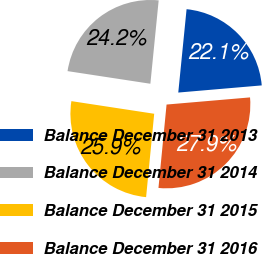Convert chart. <chart><loc_0><loc_0><loc_500><loc_500><pie_chart><fcel>Balance December 31 2013<fcel>Balance December 31 2014<fcel>Balance December 31 2015<fcel>Balance December 31 2016<nl><fcel>22.06%<fcel>24.17%<fcel>25.87%<fcel>27.9%<nl></chart> 